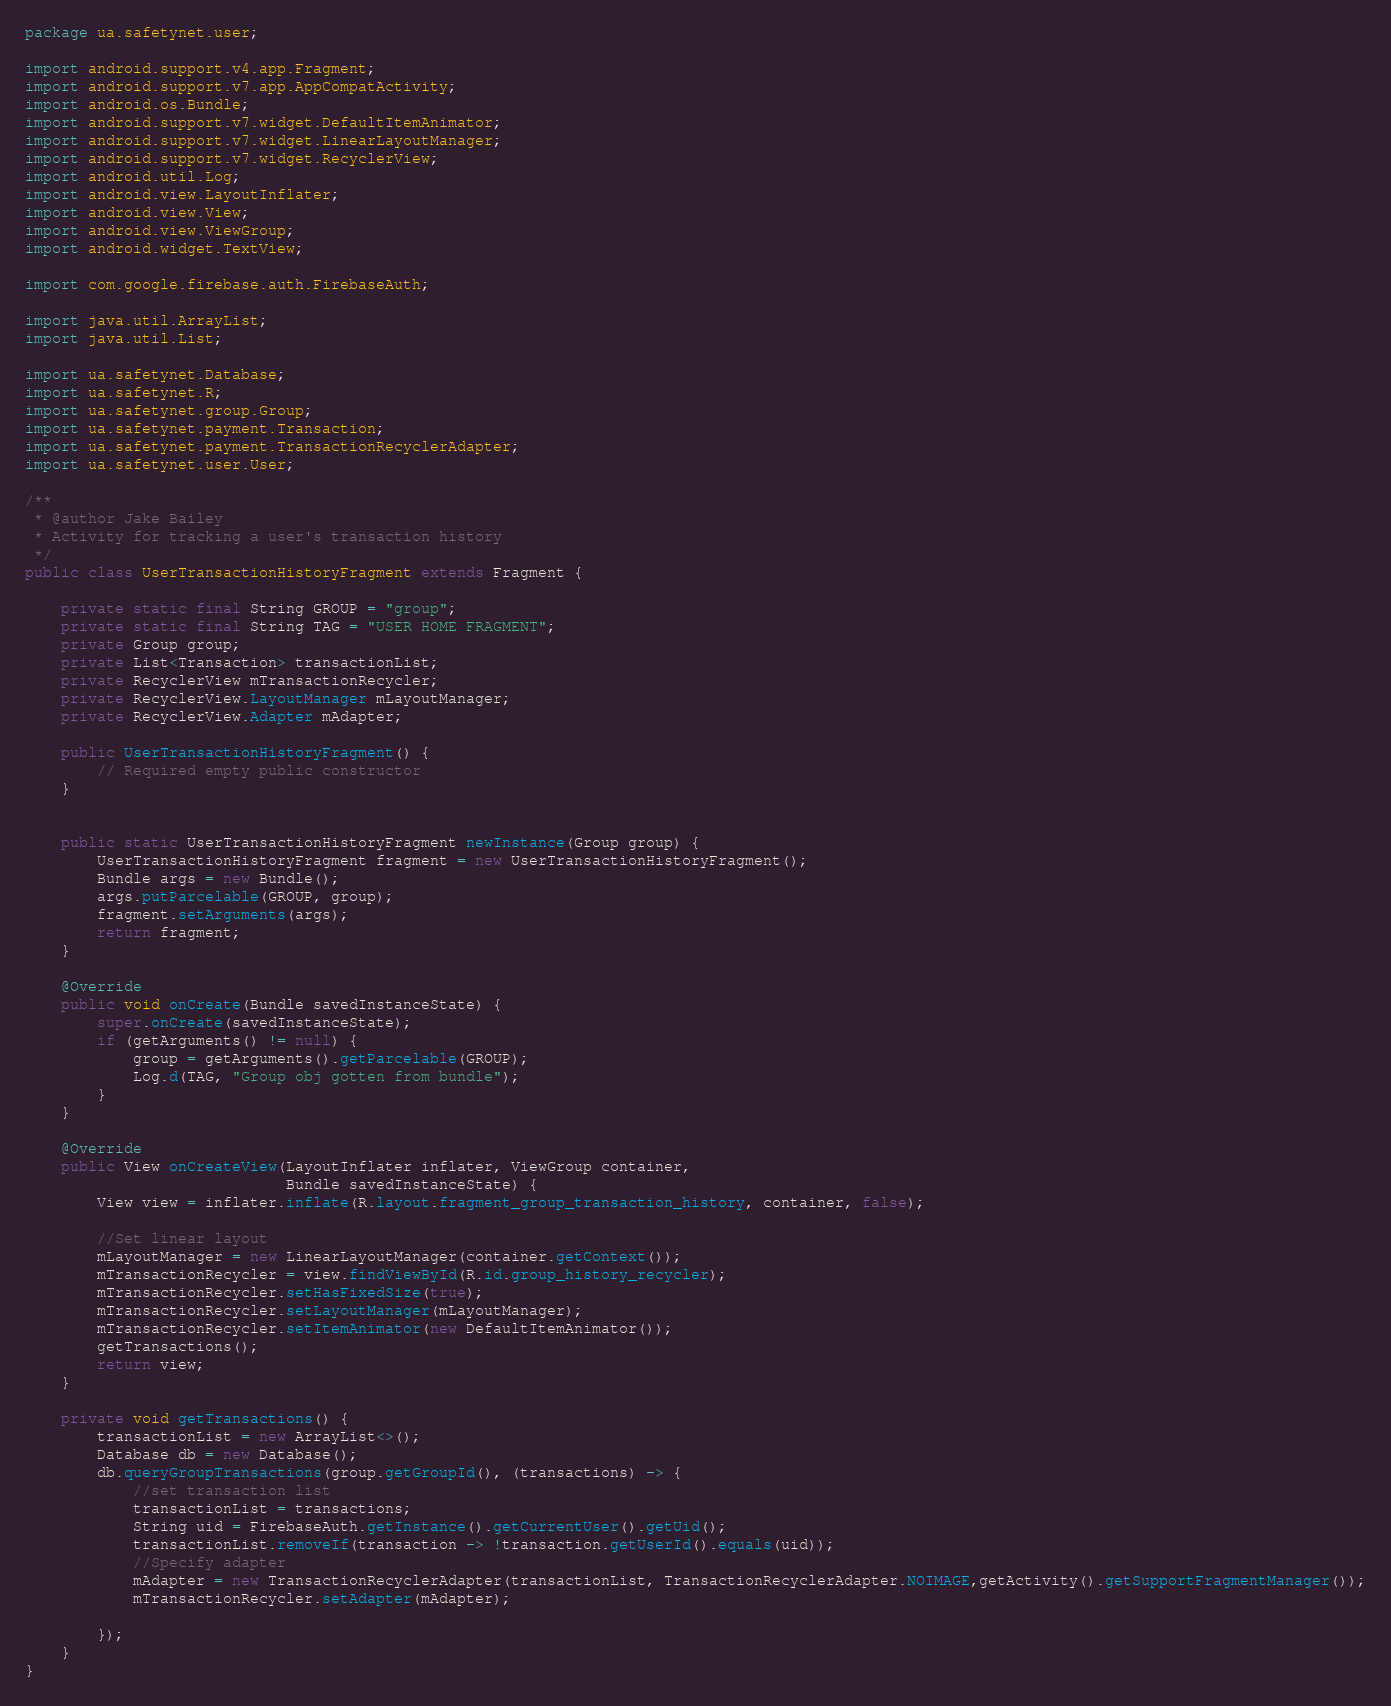Convert code to text. <code><loc_0><loc_0><loc_500><loc_500><_Java_>package ua.safetynet.user;

import android.support.v4.app.Fragment;
import android.support.v7.app.AppCompatActivity;
import android.os.Bundle;
import android.support.v7.widget.DefaultItemAnimator;
import android.support.v7.widget.LinearLayoutManager;
import android.support.v7.widget.RecyclerView;
import android.util.Log;
import android.view.LayoutInflater;
import android.view.View;
import android.view.ViewGroup;
import android.widget.TextView;

import com.google.firebase.auth.FirebaseAuth;

import java.util.ArrayList;
import java.util.List;

import ua.safetynet.Database;
import ua.safetynet.R;
import ua.safetynet.group.Group;
import ua.safetynet.payment.Transaction;
import ua.safetynet.payment.TransactionRecyclerAdapter;
import ua.safetynet.user.User;

/**
 * @author Jake Bailey
 * Activity for tracking a user's transaction history
 */
public class UserTransactionHistoryFragment extends Fragment {

    private static final String GROUP = "group";
    private static final String TAG = "USER HOME FRAGMENT";
    private Group group;
    private List<Transaction> transactionList;
    private RecyclerView mTransactionRecycler;
    private RecyclerView.LayoutManager mLayoutManager;
    private RecyclerView.Adapter mAdapter;

    public UserTransactionHistoryFragment() {
        // Required empty public constructor
    }


    public static UserTransactionHistoryFragment newInstance(Group group) {
        UserTransactionHistoryFragment fragment = new UserTransactionHistoryFragment();
        Bundle args = new Bundle();
        args.putParcelable(GROUP, group);
        fragment.setArguments(args);
        return fragment;
    }

    @Override
    public void onCreate(Bundle savedInstanceState) {
        super.onCreate(savedInstanceState);
        if (getArguments() != null) {
            group = getArguments().getParcelable(GROUP);
            Log.d(TAG, "Group obj gotten from bundle");
        }
    }

    @Override
    public View onCreateView(LayoutInflater inflater, ViewGroup container,
                             Bundle savedInstanceState) {
        View view = inflater.inflate(R.layout.fragment_group_transaction_history, container, false);

        //Set linear layout
        mLayoutManager = new LinearLayoutManager(container.getContext());
        mTransactionRecycler = view.findViewById(R.id.group_history_recycler);
        mTransactionRecycler.setHasFixedSize(true);
        mTransactionRecycler.setLayoutManager(mLayoutManager);
        mTransactionRecycler.setItemAnimator(new DefaultItemAnimator());
        getTransactions();
        return view;
    }

    private void getTransactions() {
        transactionList = new ArrayList<>();
        Database db = new Database();
        db.queryGroupTransactions(group.getGroupId(), (transactions) -> {
            //set transaction list
            transactionList = transactions;
            String uid = FirebaseAuth.getInstance().getCurrentUser().getUid();
            transactionList.removeIf(transaction -> !transaction.getUserId().equals(uid));
            //Specify adapter
            mAdapter = new TransactionRecyclerAdapter(transactionList, TransactionRecyclerAdapter.NOIMAGE,getActivity().getSupportFragmentManager());
            mTransactionRecycler.setAdapter(mAdapter);

        });
    }
}</code> 